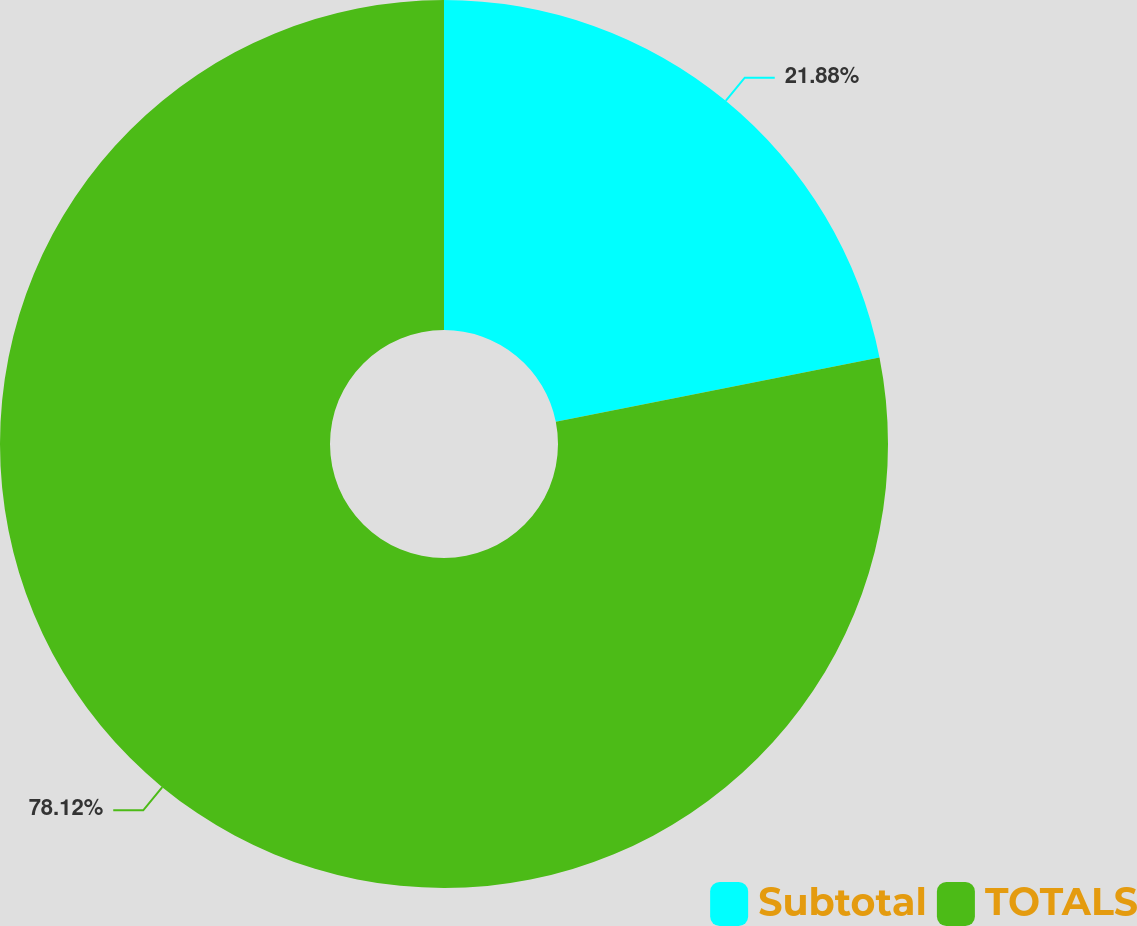Convert chart to OTSL. <chart><loc_0><loc_0><loc_500><loc_500><pie_chart><fcel>Subtotal<fcel>TOTALS<nl><fcel>21.88%<fcel>78.12%<nl></chart> 